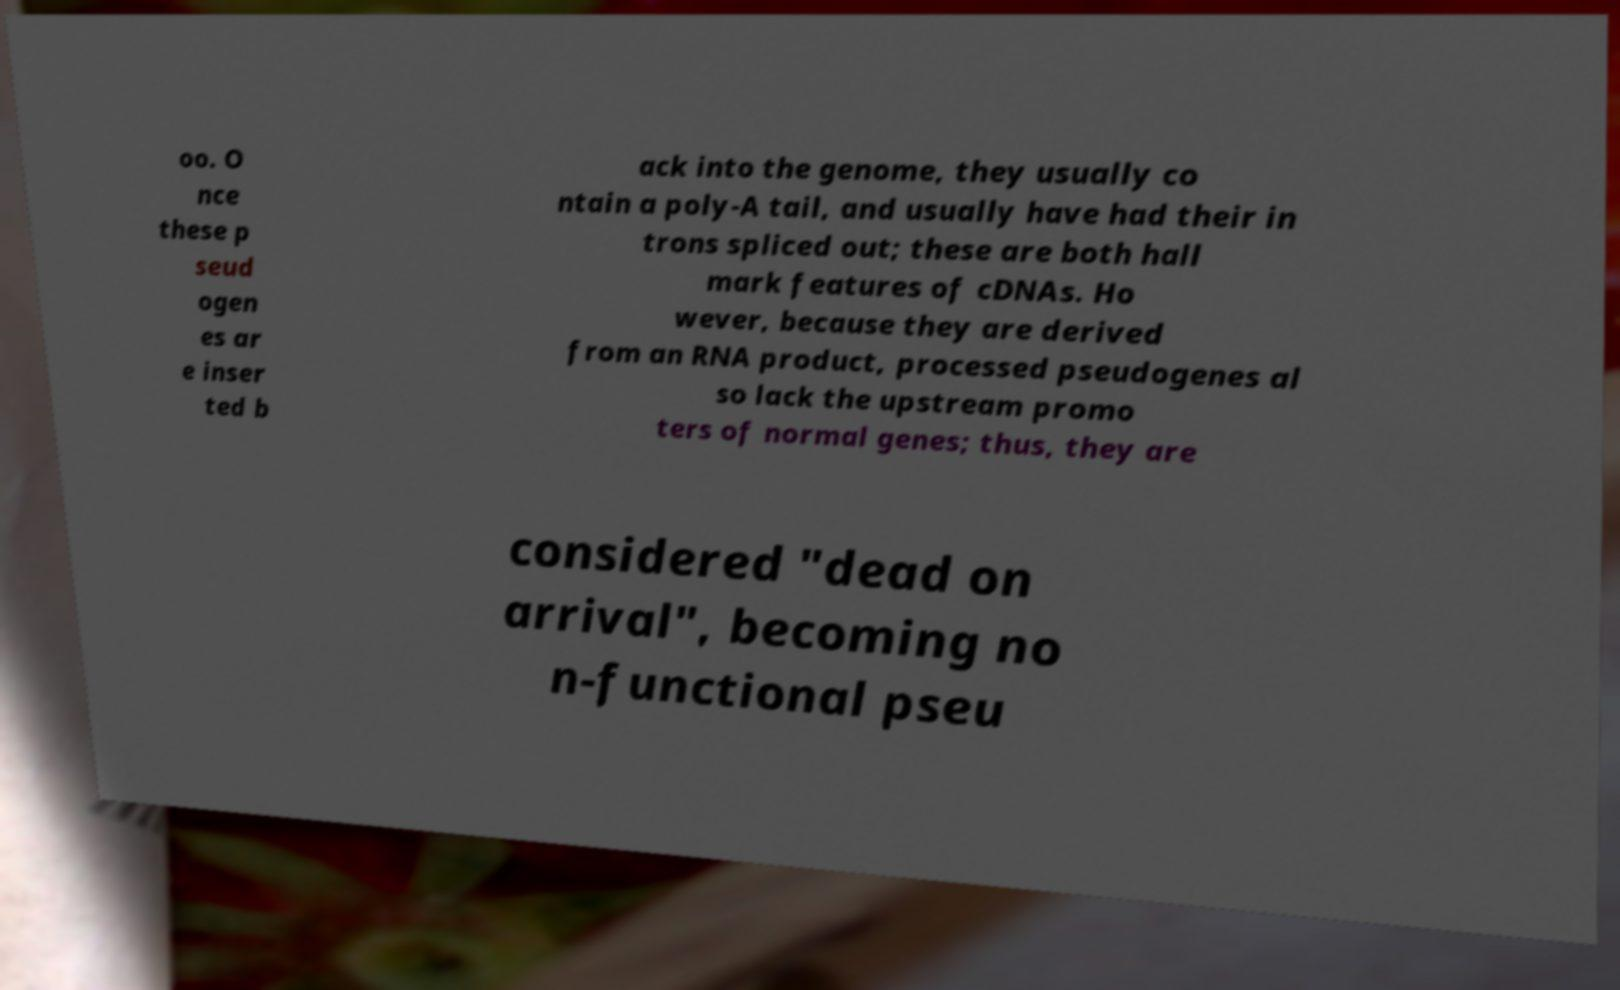Can you read and provide the text displayed in the image?This photo seems to have some interesting text. Can you extract and type it out for me? oo. O nce these p seud ogen es ar e inser ted b ack into the genome, they usually co ntain a poly-A tail, and usually have had their in trons spliced out; these are both hall mark features of cDNAs. Ho wever, because they are derived from an RNA product, processed pseudogenes al so lack the upstream promo ters of normal genes; thus, they are considered "dead on arrival", becoming no n-functional pseu 